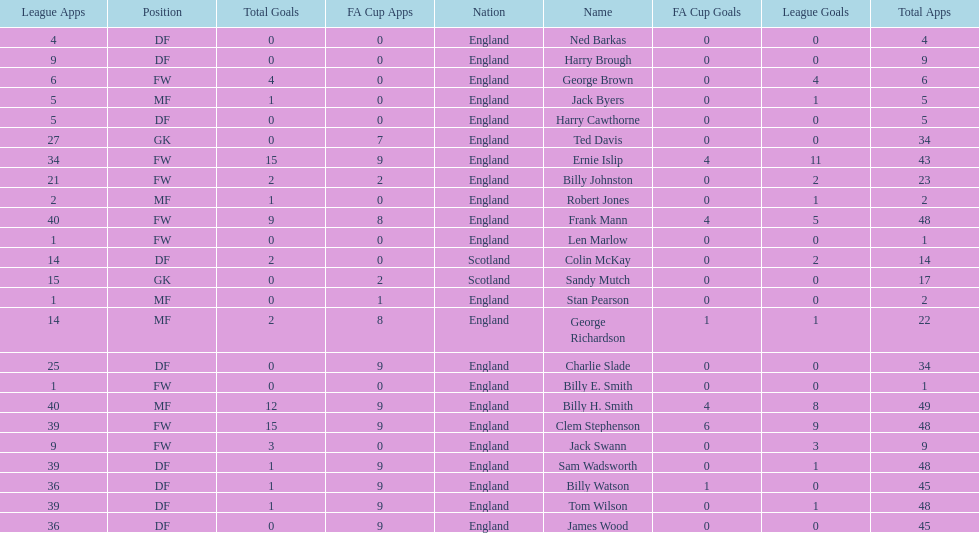The least number of total appearances 1. 